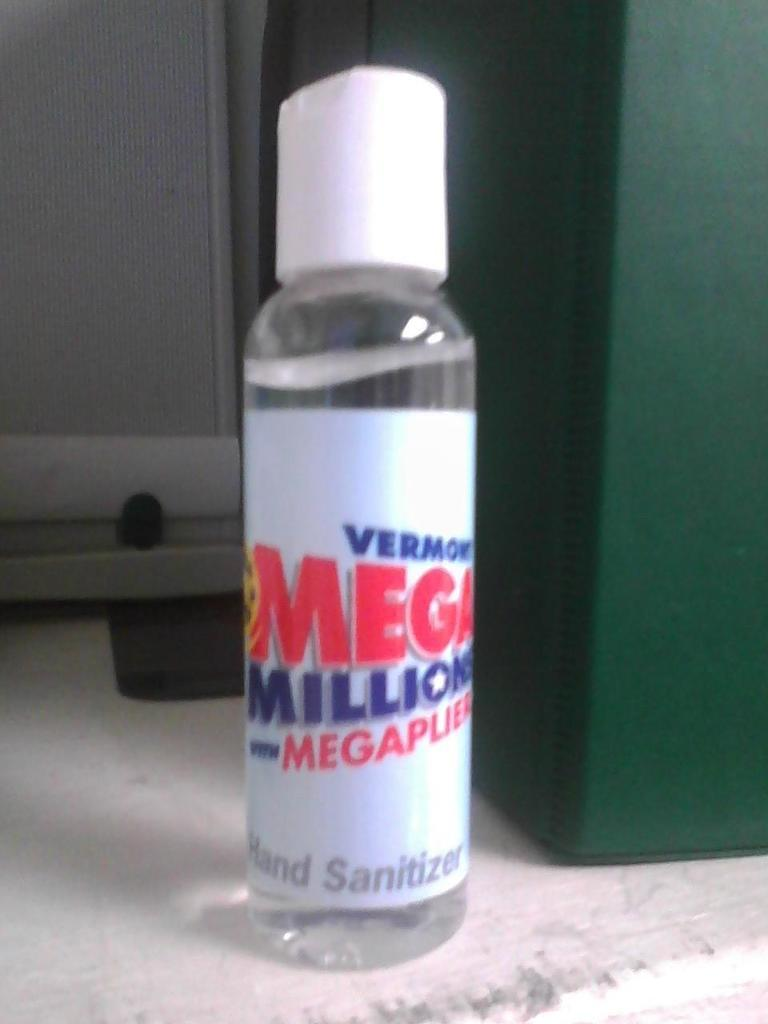What is the main object in the image? There is a bottle in the image. What is written on the bottle? The bottle has "Mega millions" written on it. What color is the object to the right side of the bottle? There is a green color thing to the right side of the bottle. What color is the cap of the bottle? The bottle has a white color cap. Can you hear the guitar being played in the image? There is no guitar present in the image, so it cannot be heard or played. 